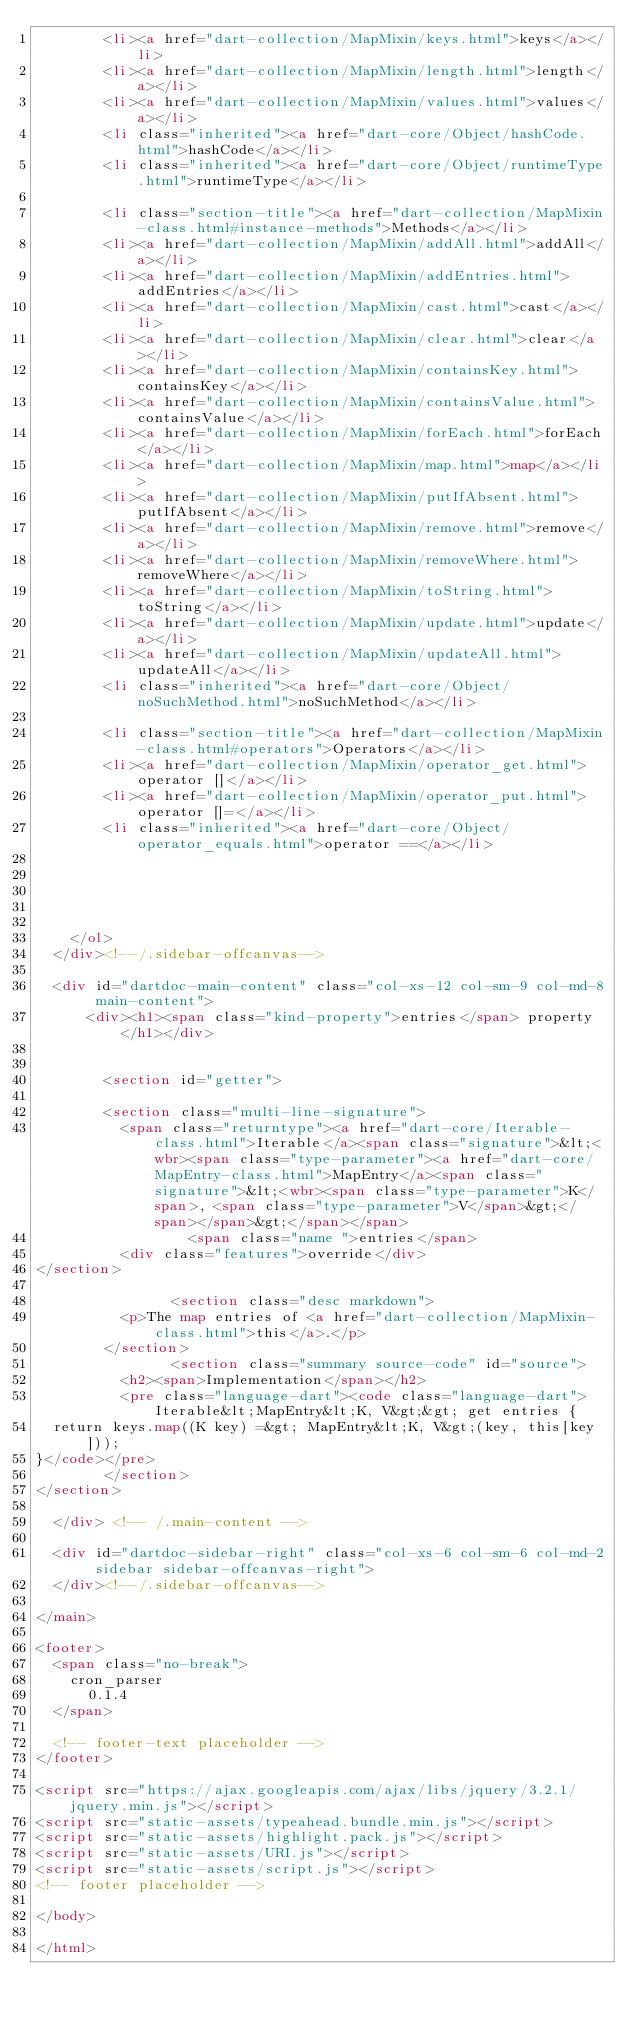<code> <loc_0><loc_0><loc_500><loc_500><_HTML_>        <li><a href="dart-collection/MapMixin/keys.html">keys</a></li>
        <li><a href="dart-collection/MapMixin/length.html">length</a></li>
        <li><a href="dart-collection/MapMixin/values.html">values</a></li>
        <li class="inherited"><a href="dart-core/Object/hashCode.html">hashCode</a></li>
        <li class="inherited"><a href="dart-core/Object/runtimeType.html">runtimeType</a></li>
    
        <li class="section-title"><a href="dart-collection/MapMixin-class.html#instance-methods">Methods</a></li>
        <li><a href="dart-collection/MapMixin/addAll.html">addAll</a></li>
        <li><a href="dart-collection/MapMixin/addEntries.html">addEntries</a></li>
        <li><a href="dart-collection/MapMixin/cast.html">cast</a></li>
        <li><a href="dart-collection/MapMixin/clear.html">clear</a></li>
        <li><a href="dart-collection/MapMixin/containsKey.html">containsKey</a></li>
        <li><a href="dart-collection/MapMixin/containsValue.html">containsValue</a></li>
        <li><a href="dart-collection/MapMixin/forEach.html">forEach</a></li>
        <li><a href="dart-collection/MapMixin/map.html">map</a></li>
        <li><a href="dart-collection/MapMixin/putIfAbsent.html">putIfAbsent</a></li>
        <li><a href="dart-collection/MapMixin/remove.html">remove</a></li>
        <li><a href="dart-collection/MapMixin/removeWhere.html">removeWhere</a></li>
        <li><a href="dart-collection/MapMixin/toString.html">toString</a></li>
        <li><a href="dart-collection/MapMixin/update.html">update</a></li>
        <li><a href="dart-collection/MapMixin/updateAll.html">updateAll</a></li>
        <li class="inherited"><a href="dart-core/Object/noSuchMethod.html">noSuchMethod</a></li>
    
        <li class="section-title"><a href="dart-collection/MapMixin-class.html#operators">Operators</a></li>
        <li><a href="dart-collection/MapMixin/operator_get.html">operator []</a></li>
        <li><a href="dart-collection/MapMixin/operator_put.html">operator []=</a></li>
        <li class="inherited"><a href="dart-core/Object/operator_equals.html">operator ==</a></li>
    
    
    
    
    
    </ol>
  </div><!--/.sidebar-offcanvas-->

  <div id="dartdoc-main-content" class="col-xs-12 col-sm-9 col-md-8 main-content">
      <div><h1><span class="kind-property">entries</span> property</h1></div>


        <section id="getter">
        
        <section class="multi-line-signature">
          <span class="returntype"><a href="dart-core/Iterable-class.html">Iterable</a><span class="signature">&lt;<wbr><span class="type-parameter"><a href="dart-core/MapEntry-class.html">MapEntry</a><span class="signature">&lt;<wbr><span class="type-parameter">K</span>, <span class="type-parameter">V</span>&gt;</span></span>&gt;</span></span>
                  <span class="name ">entries</span>
          <div class="features">override</div>
</section>
        
                <section class="desc markdown">
          <p>The map entries of <a href="dart-collection/MapMixin-class.html">this</a>.</p>
        </section>
                <section class="summary source-code" id="source">
          <h2><span>Implementation</span></h2>
          <pre class="language-dart"><code class="language-dart">Iterable&lt;MapEntry&lt;K, V&gt;&gt; get entries {
  return keys.map((K key) =&gt; MapEntry&lt;K, V&gt;(key, this[key]));
}</code></pre>
        </section>
</section>
        
  </div> <!-- /.main-content -->

  <div id="dartdoc-sidebar-right" class="col-xs-6 col-sm-6 col-md-2 sidebar sidebar-offcanvas-right">
  </div><!--/.sidebar-offcanvas-->

</main>

<footer>
  <span class="no-break">
    cron_parser
      0.1.4
  </span>

  <!-- footer-text placeholder -->
</footer>

<script src="https://ajax.googleapis.com/ajax/libs/jquery/3.2.1/jquery.min.js"></script>
<script src="static-assets/typeahead.bundle.min.js"></script>
<script src="static-assets/highlight.pack.js"></script>
<script src="static-assets/URI.js"></script>
<script src="static-assets/script.js"></script>
<!-- footer placeholder -->

</body>

</html>
</code> 